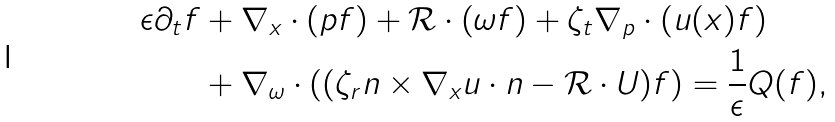<formula> <loc_0><loc_0><loc_500><loc_500>\epsilon \partial _ { t } f & + \nabla _ { x } \cdot ( p f ) + \mathcal { R } \cdot ( \omega f ) + \zeta _ { t } \nabla _ { p } \cdot ( u ( x ) f ) \\ \quad & + \nabla _ { \omega } \cdot ( ( \zeta _ { r } n \times \nabla _ { x } u \cdot n - \mathcal { R } \cdot U ) f ) = \frac { 1 } { \epsilon } Q ( f ) ,</formula> 